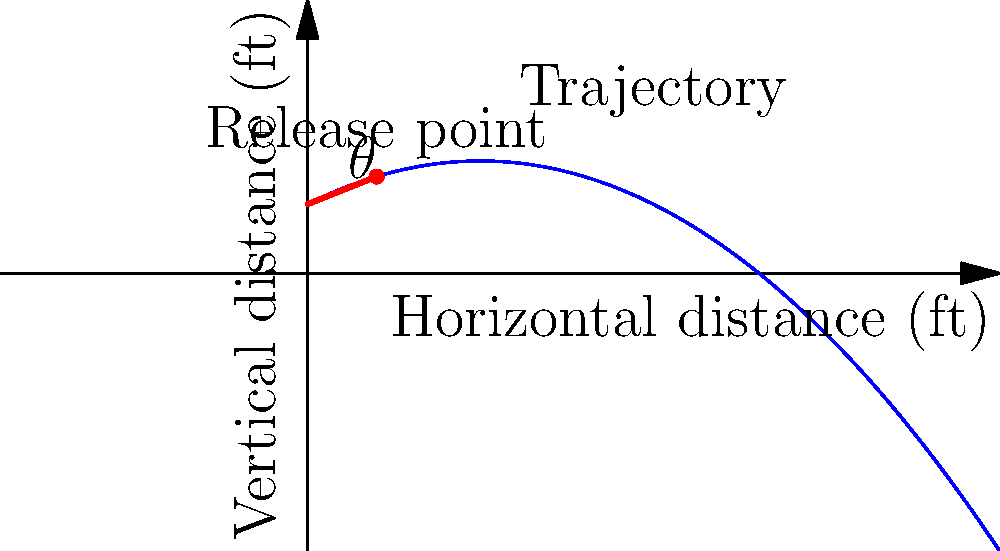In the biomechanics of throwing a baseball, what is the significance of the release angle ($\theta$) shown in the diagram, and how does it relate to the maximum distance the ball can travel? To understand the significance of the release angle in throwing a baseball, let's break it down step-by-step:

1. The release angle ($\theta$) is the angle at which the ball leaves the pitcher's hand relative to the horizontal plane.

2. In projectile motion, which applies to a thrown baseball, the release angle affects two key components:
   a) The initial vertical velocity
   b) The initial horizontal velocity

3. These initial velocities are related to the total initial velocity ($v_0$) by:
   $v_{0y} = v_0 \sin(\theta)$ (vertical component)
   $v_{0x} = v_0 \cos(\theta)$ (horizontal component)

4. The maximum distance (range) of a projectile is given by the equation:
   $R = \frac{v_0^2 \sin(2\theta)}{g}$
   Where $g$ is the acceleration due to gravity (approximately 9.8 m/s²)

5. The $\sin(2\theta)$ term in this equation reaches its maximum value when $2\theta = 90°$, or when $\theta = 45°$.

6. Therefore, for a given initial velocity, the maximum distance is achieved when the release angle is 45°.

7. However, in baseball, other factors come into play:
   a) Air resistance (which increases with velocity)
   b) The need for accuracy (lower angles are often more accurate)
   c) The height difference between the release point and the target (usually the catcher's mitt)

8. Due to these factors, the optimal release angle for a baseball pitch is typically slightly lower than 45°, usually around 30-35°.

9. Different types of pitches (fastball, curveball, etc.) may have slightly different optimal release angles based on their intended trajectory and spin.
Answer: The release angle determines the ball's trajectory and distance, with 45° theoretically maximizing distance, but practical optimal angles in baseball are typically 30-35° due to air resistance and accuracy considerations. 